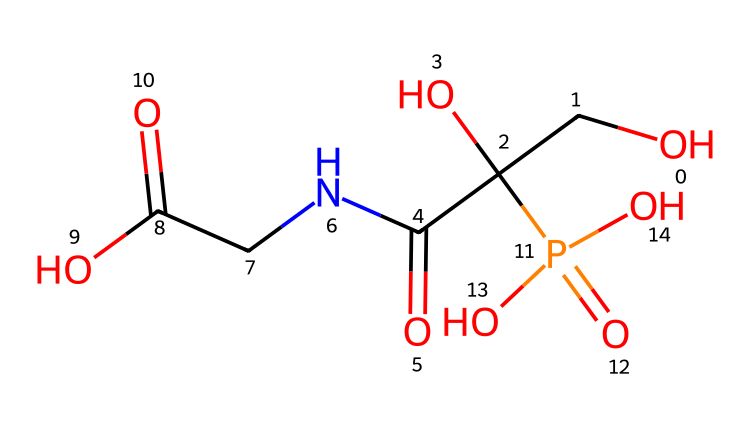What is the molecular formula of glyphosate? The molecular formula can be derived from the SMILES representation by identifying the types and quantities of each atom present. Counting the atoms: Carbon (C) = 3, Hydrogen (H) = 8, Nitrogen (N) = 1, Oxygen (O) = 5, and Phosphorus (P) = 1. Therefore, the molecular formula is C3H8N1O5P1.
Answer: C3H8N1O5P1 How many carbon atoms are present in glyphosate? Looking at the SMILES string, we can identify each carbon atom. There are three visible carbon symbols (C), thus indicating there are three carbon atoms.
Answer: 3 What type of functional groups are present in glyphosate? The SMILES string suggests various functional groups. The presence of the carboxylic acid (due to the -COOH), an amine (from the -NH3), and ester groups (due to the phosphate) indicate that glyphosate has multiple functionalities, including a phosphonic acid moiety.
Answer: carboxylic acid, amine, phosphate What is the oxidation state of phosphorus in glyphosate? In glyphosate, phosphorus is part of the phosphate group, which tends to have an oxidation state of +5. This is determined by analyzing the bonding environment in the phosphate group, where phosphorus is bonded to four oxygen atoms (three with double bonds and one with a -O) and typically has an oxidation state of +5 in such contexts.
Answer: +5 How many total oxygen atoms are there in glyphosate? Reviewing the SMILES representation, the oxygen atoms are represented by the 'O' symbols. By counting them, we find a total of five oxygen atoms present.
Answer: 5 Is glyphosate classified as acidic or basic? The presence of the carboxylic acid functional group in glyphosate imparts acidic properties. Analyzing the structure, we note the -COOH moiety, which is characteristic of acid. Thus, glyphosate is classified as acidic.
Answer: acidic 